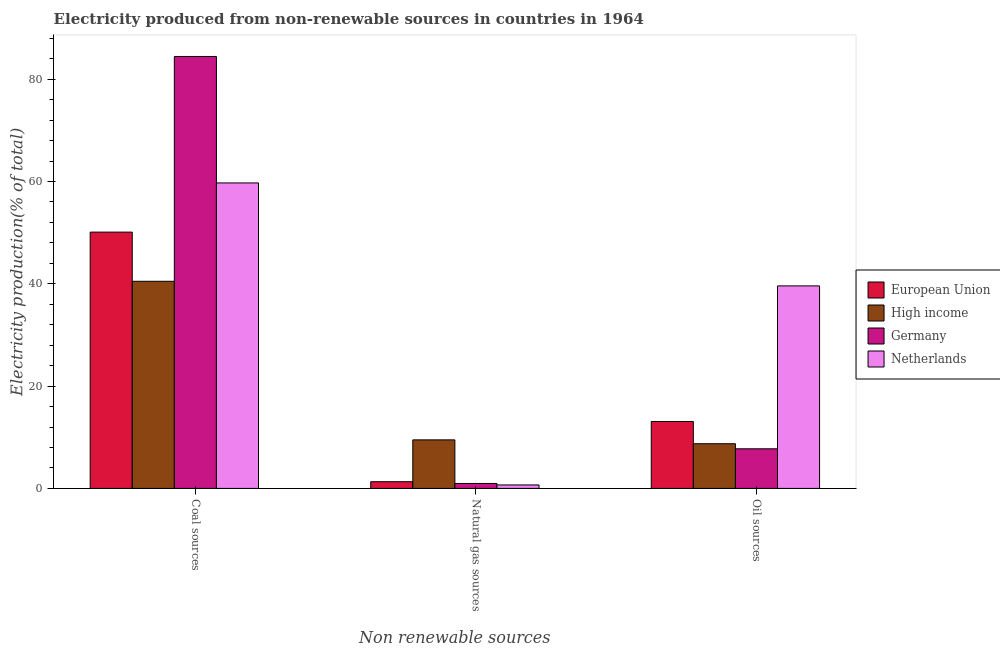How many different coloured bars are there?
Offer a very short reply. 4. Are the number of bars on each tick of the X-axis equal?
Provide a succinct answer. Yes. What is the label of the 2nd group of bars from the left?
Keep it short and to the point. Natural gas sources. What is the percentage of electricity produced by oil sources in Germany?
Make the answer very short. 7.75. Across all countries, what is the maximum percentage of electricity produced by oil sources?
Give a very brief answer. 39.6. Across all countries, what is the minimum percentage of electricity produced by oil sources?
Provide a succinct answer. 7.75. In which country was the percentage of electricity produced by natural gas maximum?
Your answer should be very brief. High income. What is the total percentage of electricity produced by coal in the graph?
Keep it short and to the point. 234.78. What is the difference between the percentage of electricity produced by coal in Germany and that in European Union?
Your response must be concise. 34.34. What is the difference between the percentage of electricity produced by coal in Germany and the percentage of electricity produced by natural gas in High income?
Offer a terse response. 74.96. What is the average percentage of electricity produced by natural gas per country?
Give a very brief answer. 3.11. What is the difference between the percentage of electricity produced by coal and percentage of electricity produced by natural gas in Germany?
Offer a very short reply. 83.48. In how many countries, is the percentage of electricity produced by coal greater than 68 %?
Give a very brief answer. 1. What is the ratio of the percentage of electricity produced by coal in Netherlands to that in European Union?
Provide a short and direct response. 1.19. What is the difference between the highest and the second highest percentage of electricity produced by coal?
Your answer should be very brief. 24.72. What is the difference between the highest and the lowest percentage of electricity produced by oil sources?
Make the answer very short. 31.85. What does the 3rd bar from the right in Coal sources represents?
Offer a terse response. High income. Are all the bars in the graph horizontal?
Your response must be concise. No. How many countries are there in the graph?
Keep it short and to the point. 4. What is the difference between two consecutive major ticks on the Y-axis?
Offer a terse response. 20. Are the values on the major ticks of Y-axis written in scientific E-notation?
Offer a very short reply. No. Does the graph contain any zero values?
Your response must be concise. No. Does the graph contain grids?
Keep it short and to the point. No. What is the title of the graph?
Your answer should be compact. Electricity produced from non-renewable sources in countries in 1964. What is the label or title of the X-axis?
Ensure brevity in your answer.  Non renewable sources. What is the Electricity production(% of total) in European Union in Coal sources?
Provide a short and direct response. 50.11. What is the Electricity production(% of total) in High income in Coal sources?
Ensure brevity in your answer.  40.5. What is the Electricity production(% of total) of Germany in Coal sources?
Ensure brevity in your answer.  84.45. What is the Electricity production(% of total) in Netherlands in Coal sources?
Keep it short and to the point. 59.73. What is the Electricity production(% of total) in European Union in Natural gas sources?
Offer a terse response. 1.31. What is the Electricity production(% of total) in High income in Natural gas sources?
Offer a very short reply. 9.49. What is the Electricity production(% of total) of Germany in Natural gas sources?
Your response must be concise. 0.97. What is the Electricity production(% of total) of Netherlands in Natural gas sources?
Give a very brief answer. 0.68. What is the Electricity production(% of total) in European Union in Oil sources?
Give a very brief answer. 13.09. What is the Electricity production(% of total) of High income in Oil sources?
Give a very brief answer. 8.74. What is the Electricity production(% of total) of Germany in Oil sources?
Keep it short and to the point. 7.75. What is the Electricity production(% of total) of Netherlands in Oil sources?
Give a very brief answer. 39.6. Across all Non renewable sources, what is the maximum Electricity production(% of total) in European Union?
Make the answer very short. 50.11. Across all Non renewable sources, what is the maximum Electricity production(% of total) of High income?
Your answer should be compact. 40.5. Across all Non renewable sources, what is the maximum Electricity production(% of total) in Germany?
Your response must be concise. 84.45. Across all Non renewable sources, what is the maximum Electricity production(% of total) in Netherlands?
Offer a very short reply. 59.73. Across all Non renewable sources, what is the minimum Electricity production(% of total) in European Union?
Your answer should be compact. 1.31. Across all Non renewable sources, what is the minimum Electricity production(% of total) in High income?
Provide a short and direct response. 8.74. Across all Non renewable sources, what is the minimum Electricity production(% of total) in Germany?
Your answer should be compact. 0.97. Across all Non renewable sources, what is the minimum Electricity production(% of total) of Netherlands?
Ensure brevity in your answer.  0.68. What is the total Electricity production(% of total) in European Union in the graph?
Offer a very short reply. 64.51. What is the total Electricity production(% of total) of High income in the graph?
Your answer should be very brief. 58.73. What is the total Electricity production(% of total) of Germany in the graph?
Your response must be concise. 93.16. What is the difference between the Electricity production(% of total) in European Union in Coal sources and that in Natural gas sources?
Your response must be concise. 48.8. What is the difference between the Electricity production(% of total) in High income in Coal sources and that in Natural gas sources?
Your answer should be compact. 31. What is the difference between the Electricity production(% of total) in Germany in Coal sources and that in Natural gas sources?
Your answer should be compact. 83.48. What is the difference between the Electricity production(% of total) in Netherlands in Coal sources and that in Natural gas sources?
Your answer should be very brief. 59.05. What is the difference between the Electricity production(% of total) in European Union in Coal sources and that in Oil sources?
Your answer should be very brief. 37.02. What is the difference between the Electricity production(% of total) of High income in Coal sources and that in Oil sources?
Your answer should be compact. 31.76. What is the difference between the Electricity production(% of total) of Germany in Coal sources and that in Oil sources?
Your answer should be very brief. 76.7. What is the difference between the Electricity production(% of total) of Netherlands in Coal sources and that in Oil sources?
Your answer should be compact. 20.13. What is the difference between the Electricity production(% of total) in European Union in Natural gas sources and that in Oil sources?
Your answer should be very brief. -11.78. What is the difference between the Electricity production(% of total) of High income in Natural gas sources and that in Oil sources?
Keep it short and to the point. 0.75. What is the difference between the Electricity production(% of total) of Germany in Natural gas sources and that in Oil sources?
Make the answer very short. -6.78. What is the difference between the Electricity production(% of total) of Netherlands in Natural gas sources and that in Oil sources?
Offer a very short reply. -38.92. What is the difference between the Electricity production(% of total) of European Union in Coal sources and the Electricity production(% of total) of High income in Natural gas sources?
Make the answer very short. 40.62. What is the difference between the Electricity production(% of total) of European Union in Coal sources and the Electricity production(% of total) of Germany in Natural gas sources?
Make the answer very short. 49.14. What is the difference between the Electricity production(% of total) of European Union in Coal sources and the Electricity production(% of total) of Netherlands in Natural gas sources?
Make the answer very short. 49.43. What is the difference between the Electricity production(% of total) of High income in Coal sources and the Electricity production(% of total) of Germany in Natural gas sources?
Keep it short and to the point. 39.53. What is the difference between the Electricity production(% of total) of High income in Coal sources and the Electricity production(% of total) of Netherlands in Natural gas sources?
Your answer should be very brief. 39.82. What is the difference between the Electricity production(% of total) of Germany in Coal sources and the Electricity production(% of total) of Netherlands in Natural gas sources?
Keep it short and to the point. 83.77. What is the difference between the Electricity production(% of total) of European Union in Coal sources and the Electricity production(% of total) of High income in Oil sources?
Provide a succinct answer. 41.37. What is the difference between the Electricity production(% of total) of European Union in Coal sources and the Electricity production(% of total) of Germany in Oil sources?
Provide a succinct answer. 42.36. What is the difference between the Electricity production(% of total) of European Union in Coal sources and the Electricity production(% of total) of Netherlands in Oil sources?
Your response must be concise. 10.51. What is the difference between the Electricity production(% of total) of High income in Coal sources and the Electricity production(% of total) of Germany in Oil sources?
Offer a very short reply. 32.75. What is the difference between the Electricity production(% of total) in High income in Coal sources and the Electricity production(% of total) in Netherlands in Oil sources?
Your answer should be very brief. 0.9. What is the difference between the Electricity production(% of total) of Germany in Coal sources and the Electricity production(% of total) of Netherlands in Oil sources?
Keep it short and to the point. 44.85. What is the difference between the Electricity production(% of total) of European Union in Natural gas sources and the Electricity production(% of total) of High income in Oil sources?
Your answer should be very brief. -7.43. What is the difference between the Electricity production(% of total) of European Union in Natural gas sources and the Electricity production(% of total) of Germany in Oil sources?
Offer a very short reply. -6.43. What is the difference between the Electricity production(% of total) in European Union in Natural gas sources and the Electricity production(% of total) in Netherlands in Oil sources?
Your response must be concise. -38.28. What is the difference between the Electricity production(% of total) in High income in Natural gas sources and the Electricity production(% of total) in Germany in Oil sources?
Keep it short and to the point. 1.75. What is the difference between the Electricity production(% of total) in High income in Natural gas sources and the Electricity production(% of total) in Netherlands in Oil sources?
Keep it short and to the point. -30.1. What is the difference between the Electricity production(% of total) in Germany in Natural gas sources and the Electricity production(% of total) in Netherlands in Oil sources?
Your answer should be compact. -38.63. What is the average Electricity production(% of total) in European Union per Non renewable sources?
Keep it short and to the point. 21.5. What is the average Electricity production(% of total) in High income per Non renewable sources?
Provide a short and direct response. 19.58. What is the average Electricity production(% of total) in Germany per Non renewable sources?
Make the answer very short. 31.05. What is the average Electricity production(% of total) in Netherlands per Non renewable sources?
Your answer should be very brief. 33.33. What is the difference between the Electricity production(% of total) of European Union and Electricity production(% of total) of High income in Coal sources?
Your answer should be very brief. 9.61. What is the difference between the Electricity production(% of total) in European Union and Electricity production(% of total) in Germany in Coal sources?
Provide a short and direct response. -34.34. What is the difference between the Electricity production(% of total) in European Union and Electricity production(% of total) in Netherlands in Coal sources?
Offer a very short reply. -9.62. What is the difference between the Electricity production(% of total) in High income and Electricity production(% of total) in Germany in Coal sources?
Provide a short and direct response. -43.95. What is the difference between the Electricity production(% of total) in High income and Electricity production(% of total) in Netherlands in Coal sources?
Ensure brevity in your answer.  -19.23. What is the difference between the Electricity production(% of total) of Germany and Electricity production(% of total) of Netherlands in Coal sources?
Ensure brevity in your answer.  24.72. What is the difference between the Electricity production(% of total) in European Union and Electricity production(% of total) in High income in Natural gas sources?
Give a very brief answer. -8.18. What is the difference between the Electricity production(% of total) of European Union and Electricity production(% of total) of Germany in Natural gas sources?
Keep it short and to the point. 0.34. What is the difference between the Electricity production(% of total) of European Union and Electricity production(% of total) of Netherlands in Natural gas sources?
Your answer should be very brief. 0.63. What is the difference between the Electricity production(% of total) in High income and Electricity production(% of total) in Germany in Natural gas sources?
Give a very brief answer. 8.52. What is the difference between the Electricity production(% of total) of High income and Electricity production(% of total) of Netherlands in Natural gas sources?
Your answer should be compact. 8.81. What is the difference between the Electricity production(% of total) of Germany and Electricity production(% of total) of Netherlands in Natural gas sources?
Your answer should be very brief. 0.29. What is the difference between the Electricity production(% of total) of European Union and Electricity production(% of total) of High income in Oil sources?
Keep it short and to the point. 4.35. What is the difference between the Electricity production(% of total) in European Union and Electricity production(% of total) in Germany in Oil sources?
Your response must be concise. 5.34. What is the difference between the Electricity production(% of total) of European Union and Electricity production(% of total) of Netherlands in Oil sources?
Give a very brief answer. -26.51. What is the difference between the Electricity production(% of total) of High income and Electricity production(% of total) of Germany in Oil sources?
Provide a succinct answer. 0.99. What is the difference between the Electricity production(% of total) of High income and Electricity production(% of total) of Netherlands in Oil sources?
Your answer should be very brief. -30.86. What is the difference between the Electricity production(% of total) in Germany and Electricity production(% of total) in Netherlands in Oil sources?
Offer a very short reply. -31.85. What is the ratio of the Electricity production(% of total) of European Union in Coal sources to that in Natural gas sources?
Give a very brief answer. 38.18. What is the ratio of the Electricity production(% of total) of High income in Coal sources to that in Natural gas sources?
Offer a terse response. 4.27. What is the ratio of the Electricity production(% of total) in Germany in Coal sources to that in Natural gas sources?
Keep it short and to the point. 87.09. What is the ratio of the Electricity production(% of total) in Netherlands in Coal sources to that in Natural gas sources?
Offer a very short reply. 87.96. What is the ratio of the Electricity production(% of total) of European Union in Coal sources to that in Oil sources?
Keep it short and to the point. 3.83. What is the ratio of the Electricity production(% of total) of High income in Coal sources to that in Oil sources?
Give a very brief answer. 4.63. What is the ratio of the Electricity production(% of total) of Germany in Coal sources to that in Oil sources?
Make the answer very short. 10.9. What is the ratio of the Electricity production(% of total) in Netherlands in Coal sources to that in Oil sources?
Offer a terse response. 1.51. What is the ratio of the Electricity production(% of total) of European Union in Natural gas sources to that in Oil sources?
Your response must be concise. 0.1. What is the ratio of the Electricity production(% of total) of High income in Natural gas sources to that in Oil sources?
Your answer should be compact. 1.09. What is the ratio of the Electricity production(% of total) of Germany in Natural gas sources to that in Oil sources?
Your answer should be compact. 0.13. What is the ratio of the Electricity production(% of total) in Netherlands in Natural gas sources to that in Oil sources?
Offer a very short reply. 0.02. What is the difference between the highest and the second highest Electricity production(% of total) in European Union?
Offer a very short reply. 37.02. What is the difference between the highest and the second highest Electricity production(% of total) of High income?
Provide a short and direct response. 31. What is the difference between the highest and the second highest Electricity production(% of total) of Germany?
Offer a terse response. 76.7. What is the difference between the highest and the second highest Electricity production(% of total) of Netherlands?
Make the answer very short. 20.13. What is the difference between the highest and the lowest Electricity production(% of total) in European Union?
Your response must be concise. 48.8. What is the difference between the highest and the lowest Electricity production(% of total) in High income?
Your answer should be compact. 31.76. What is the difference between the highest and the lowest Electricity production(% of total) of Germany?
Ensure brevity in your answer.  83.48. What is the difference between the highest and the lowest Electricity production(% of total) in Netherlands?
Offer a terse response. 59.05. 